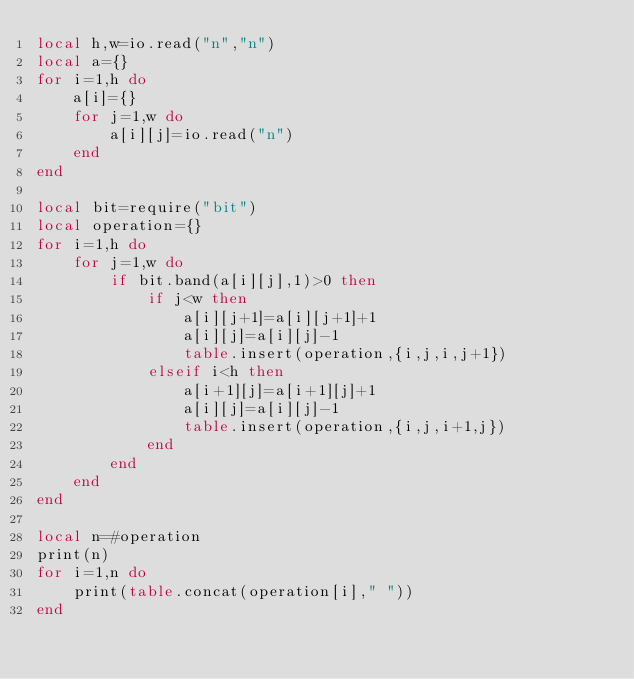<code> <loc_0><loc_0><loc_500><loc_500><_Lua_>local h,w=io.read("n","n")
local a={}
for i=1,h do
    a[i]={}
    for j=1,w do
        a[i][j]=io.read("n")
    end
end

local bit=require("bit")
local operation={}
for i=1,h do
    for j=1,w do
        if bit.band(a[i][j],1)>0 then
            if j<w then
                a[i][j+1]=a[i][j+1]+1
                a[i][j]=a[i][j]-1
                table.insert(operation,{i,j,i,j+1})
            elseif i<h then
                a[i+1][j]=a[i+1][j]+1
                a[i][j]=a[i][j]-1
                table.insert(operation,{i,j,i+1,j})
            end
        end
    end
end

local n=#operation
print(n)
for i=1,n do
    print(table.concat(operation[i]," "))
end</code> 